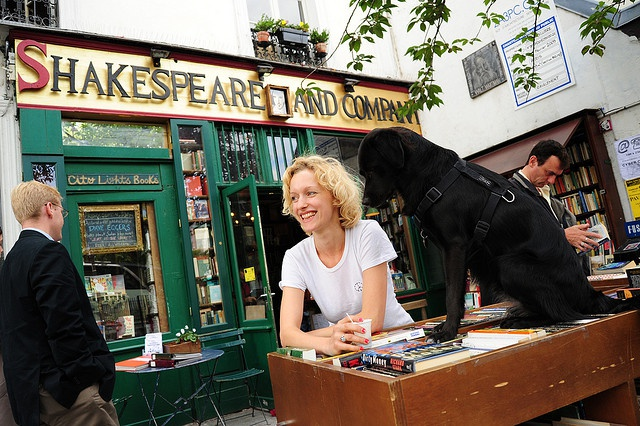Describe the objects in this image and their specific colors. I can see dog in black and gray tones, people in black, tan, and gray tones, people in black, lightgray, and tan tones, book in black, teal, gray, and darkgray tones, and chair in black, teal, and gray tones in this image. 